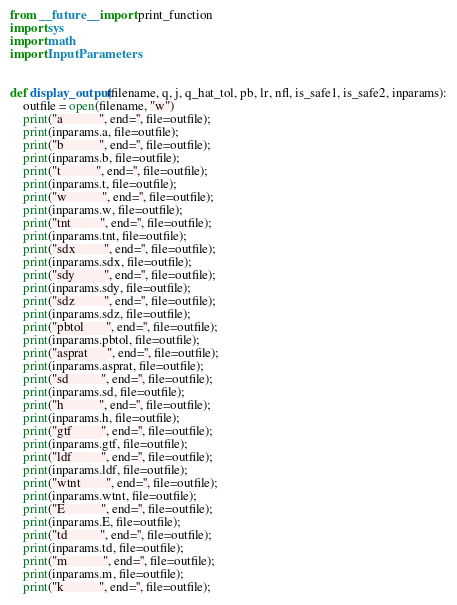<code> <loc_0><loc_0><loc_500><loc_500><_Python_>from __future__ import print_function
import sys
import math
import InputParameters


def display_output(filename, q, j, q_hat_tol, pb, lr, nfl, is_safe1, is_safe2, inparams):
    outfile = open(filename, "w")
    print("a           ", end='', file=outfile);
    print(inparams.a, file=outfile);
    print("b           ", end='', file=outfile);
    print(inparams.b, file=outfile);
    print("t           ", end='', file=outfile);
    print(inparams.t, file=outfile);
    print("w           ", end='', file=outfile);
    print(inparams.w, file=outfile);
    print("tnt         ", end='', file=outfile);
    print(inparams.tnt, file=outfile);
    print("sdx         ", end='', file=outfile);
    print(inparams.sdx, file=outfile);
    print("sdy         ", end='', file=outfile);
    print(inparams.sdy, file=outfile);
    print("sdz         ", end='', file=outfile);
    print(inparams.sdz, file=outfile);
    print("pbtol       ", end='', file=outfile);
    print(inparams.pbtol, file=outfile);
    print("asprat      ", end='', file=outfile);
    print(inparams.asprat, file=outfile);
    print("sd          ", end='', file=outfile);
    print(inparams.sd, file=outfile);
    print("h           ", end='', file=outfile);
    print(inparams.h, file=outfile);
    print("gtf         ", end='', file=outfile);
    print(inparams.gtf, file=outfile);
    print("ldf         ", end='', file=outfile);
    print(inparams.ldf, file=outfile);
    print("wtnt        ", end='', file=outfile);
    print(inparams.wtnt, file=outfile);
    print("E           ", end='', file=outfile);
    print(inparams.E, file=outfile);
    print("td          ", end='', file=outfile);
    print(inparams.td, file=outfile);
    print("m           ", end='', file=outfile);
    print(inparams.m, file=outfile);
    print("k           ", end='', file=outfile);</code> 